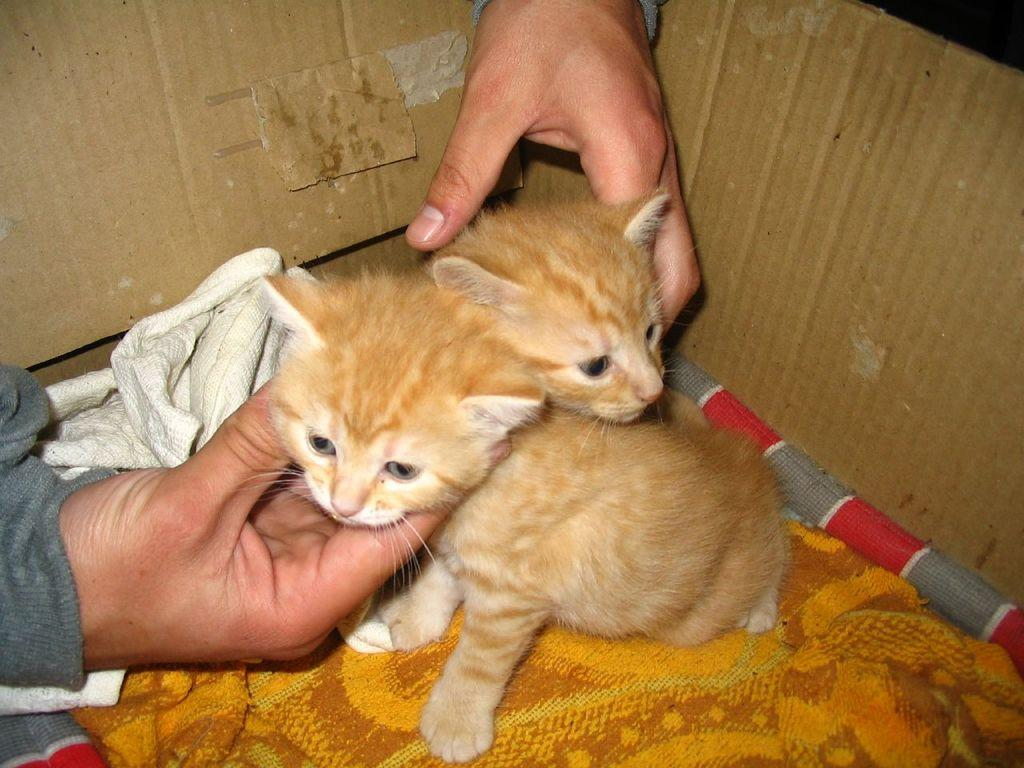How many cats are present in the image? There are two cats in the image. What color are the cats? The cats are brown in color. Where are the cats located in the image? The cats are in a cardboard box. What else can be found in the cardboard box? There is some cloth in the cardboard box. Whose hand is visible in the image? A person's hand is visible in the image. What type of kettle is being used to lead the cats in the image? There is no kettle or any indication of leading the cats in the image. 